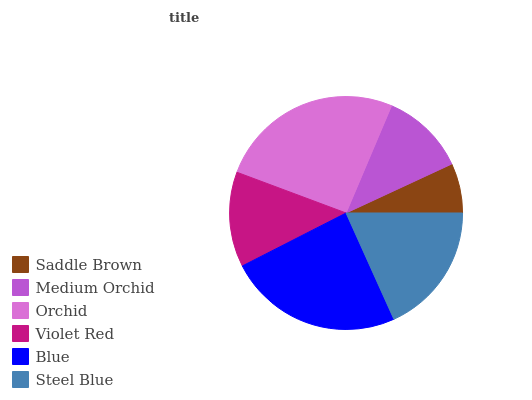Is Saddle Brown the minimum?
Answer yes or no. Yes. Is Orchid the maximum?
Answer yes or no. Yes. Is Medium Orchid the minimum?
Answer yes or no. No. Is Medium Orchid the maximum?
Answer yes or no. No. Is Medium Orchid greater than Saddle Brown?
Answer yes or no. Yes. Is Saddle Brown less than Medium Orchid?
Answer yes or no. Yes. Is Saddle Brown greater than Medium Orchid?
Answer yes or no. No. Is Medium Orchid less than Saddle Brown?
Answer yes or no. No. Is Steel Blue the high median?
Answer yes or no. Yes. Is Violet Red the low median?
Answer yes or no. Yes. Is Orchid the high median?
Answer yes or no. No. Is Saddle Brown the low median?
Answer yes or no. No. 